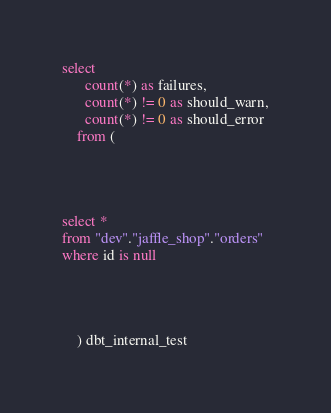<code> <loc_0><loc_0><loc_500><loc_500><_SQL_>select
      count(*) as failures,
      count(*) != 0 as should_warn,
      count(*) != 0 as should_error
    from (
      
    
    

select *
from "dev"."jaffle_shop"."orders"
where id is null



      
    ) dbt_internal_test</code> 